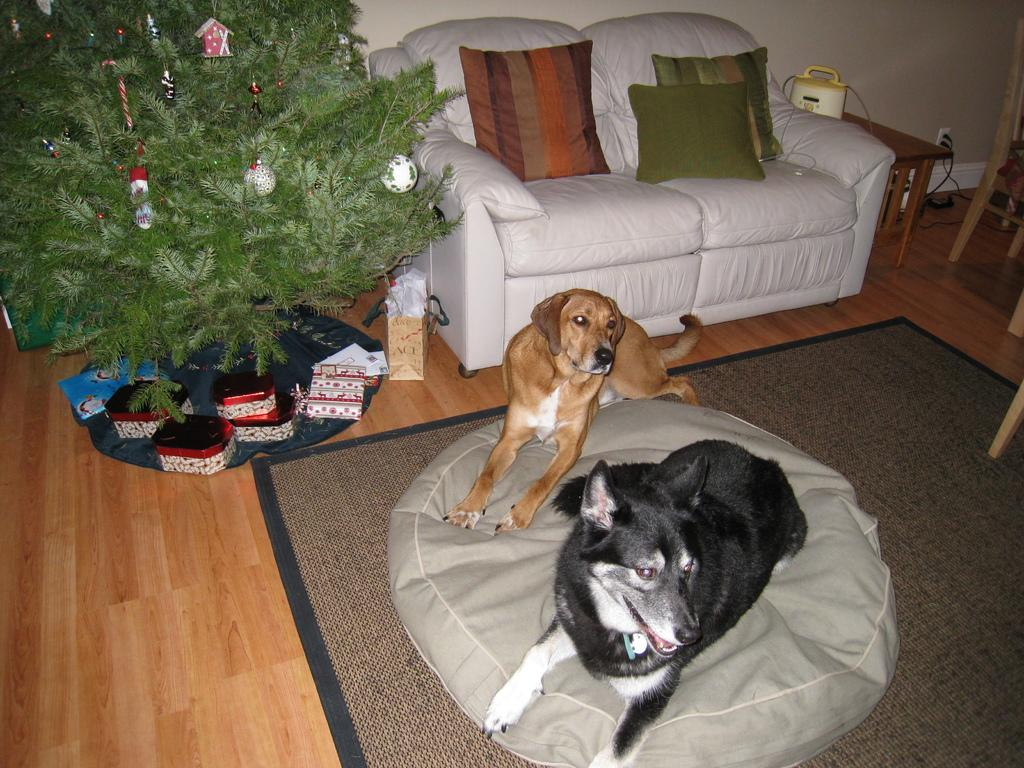What animals are sitting on the bean bag in the image? There are dogs sitting on a bean bag in the image. What type of furniture is visible in the image? There is a couch with cushions in the image. What type of vegetation is present in the image? There is a plant beside the couch. What type of copper material can be seen in the image? There is no copper material present in the image. How many kittens are playing with the ant on the couch? There are no kittens or ants present in the image. 